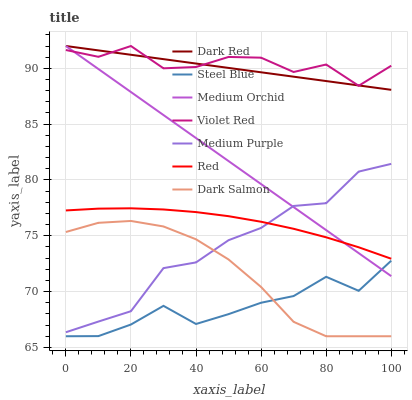Does Dark Red have the minimum area under the curve?
Answer yes or no. No. Does Dark Red have the maximum area under the curve?
Answer yes or no. No. Is Medium Orchid the smoothest?
Answer yes or no. No. Is Medium Orchid the roughest?
Answer yes or no. No. Does Dark Red have the lowest value?
Answer yes or no. No. Does Steel Blue have the highest value?
Answer yes or no. No. Is Dark Salmon less than Dark Red?
Answer yes or no. Yes. Is Violet Red greater than Dark Salmon?
Answer yes or no. Yes. Does Dark Salmon intersect Dark Red?
Answer yes or no. No. 